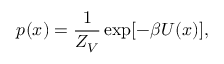Convert formula to latex. <formula><loc_0><loc_0><loc_500><loc_500>p ( x ) = \frac { 1 } { Z _ { V } } \exp [ - \beta U ( x ) ] ,</formula> 